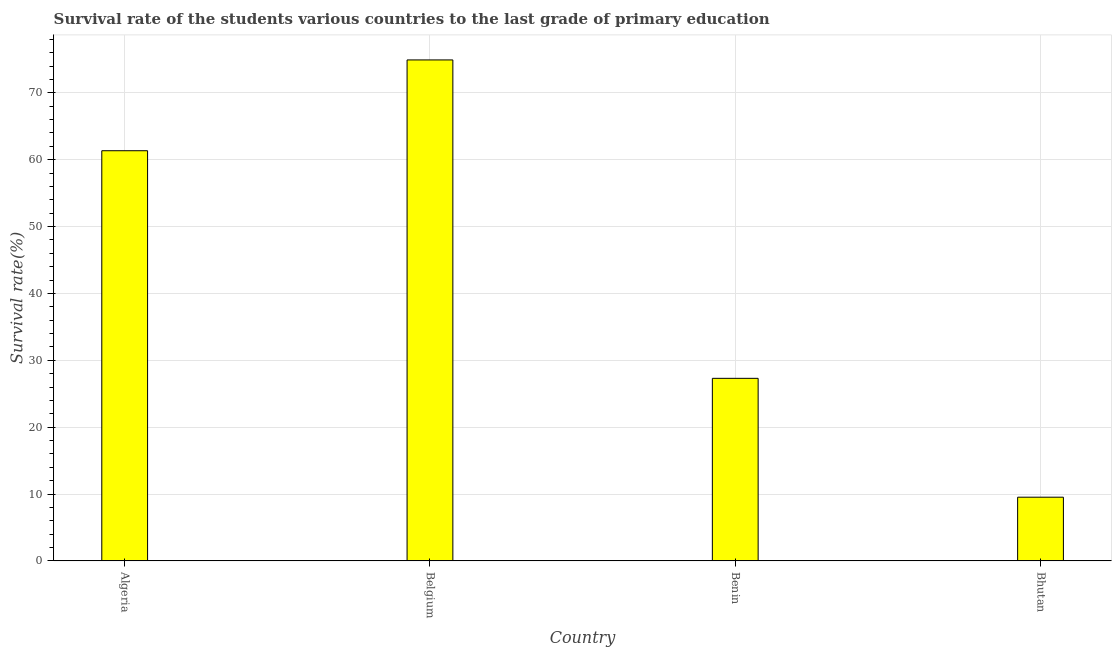Does the graph contain grids?
Offer a terse response. Yes. What is the title of the graph?
Your answer should be very brief. Survival rate of the students various countries to the last grade of primary education. What is the label or title of the X-axis?
Offer a very short reply. Country. What is the label or title of the Y-axis?
Offer a very short reply. Survival rate(%). What is the survival rate in primary education in Bhutan?
Keep it short and to the point. 9.53. Across all countries, what is the maximum survival rate in primary education?
Make the answer very short. 74.92. Across all countries, what is the minimum survival rate in primary education?
Ensure brevity in your answer.  9.53. In which country was the survival rate in primary education minimum?
Your answer should be very brief. Bhutan. What is the sum of the survival rate in primary education?
Keep it short and to the point. 173.09. What is the difference between the survival rate in primary education in Belgium and Bhutan?
Provide a short and direct response. 65.39. What is the average survival rate in primary education per country?
Provide a succinct answer. 43.27. What is the median survival rate in primary education?
Your answer should be compact. 44.32. In how many countries, is the survival rate in primary education greater than 2 %?
Provide a short and direct response. 4. What is the ratio of the survival rate in primary education in Benin to that in Bhutan?
Your response must be concise. 2.87. Is the survival rate in primary education in Belgium less than that in Benin?
Offer a terse response. No. What is the difference between the highest and the second highest survival rate in primary education?
Offer a very short reply. 13.58. What is the difference between the highest and the lowest survival rate in primary education?
Your response must be concise. 65.39. In how many countries, is the survival rate in primary education greater than the average survival rate in primary education taken over all countries?
Provide a succinct answer. 2. How many bars are there?
Ensure brevity in your answer.  4. What is the difference between two consecutive major ticks on the Y-axis?
Give a very brief answer. 10. Are the values on the major ticks of Y-axis written in scientific E-notation?
Your answer should be very brief. No. What is the Survival rate(%) of Algeria?
Ensure brevity in your answer.  61.34. What is the Survival rate(%) of Belgium?
Provide a succinct answer. 74.92. What is the Survival rate(%) of Benin?
Ensure brevity in your answer.  27.3. What is the Survival rate(%) in Bhutan?
Offer a very short reply. 9.53. What is the difference between the Survival rate(%) in Algeria and Belgium?
Your answer should be compact. -13.58. What is the difference between the Survival rate(%) in Algeria and Benin?
Give a very brief answer. 34.04. What is the difference between the Survival rate(%) in Algeria and Bhutan?
Make the answer very short. 51.81. What is the difference between the Survival rate(%) in Belgium and Benin?
Offer a terse response. 47.62. What is the difference between the Survival rate(%) in Belgium and Bhutan?
Ensure brevity in your answer.  65.39. What is the difference between the Survival rate(%) in Benin and Bhutan?
Keep it short and to the point. 17.77. What is the ratio of the Survival rate(%) in Algeria to that in Belgium?
Offer a very short reply. 0.82. What is the ratio of the Survival rate(%) in Algeria to that in Benin?
Offer a terse response. 2.25. What is the ratio of the Survival rate(%) in Algeria to that in Bhutan?
Ensure brevity in your answer.  6.44. What is the ratio of the Survival rate(%) in Belgium to that in Benin?
Give a very brief answer. 2.74. What is the ratio of the Survival rate(%) in Belgium to that in Bhutan?
Ensure brevity in your answer.  7.86. What is the ratio of the Survival rate(%) in Benin to that in Bhutan?
Your answer should be very brief. 2.87. 